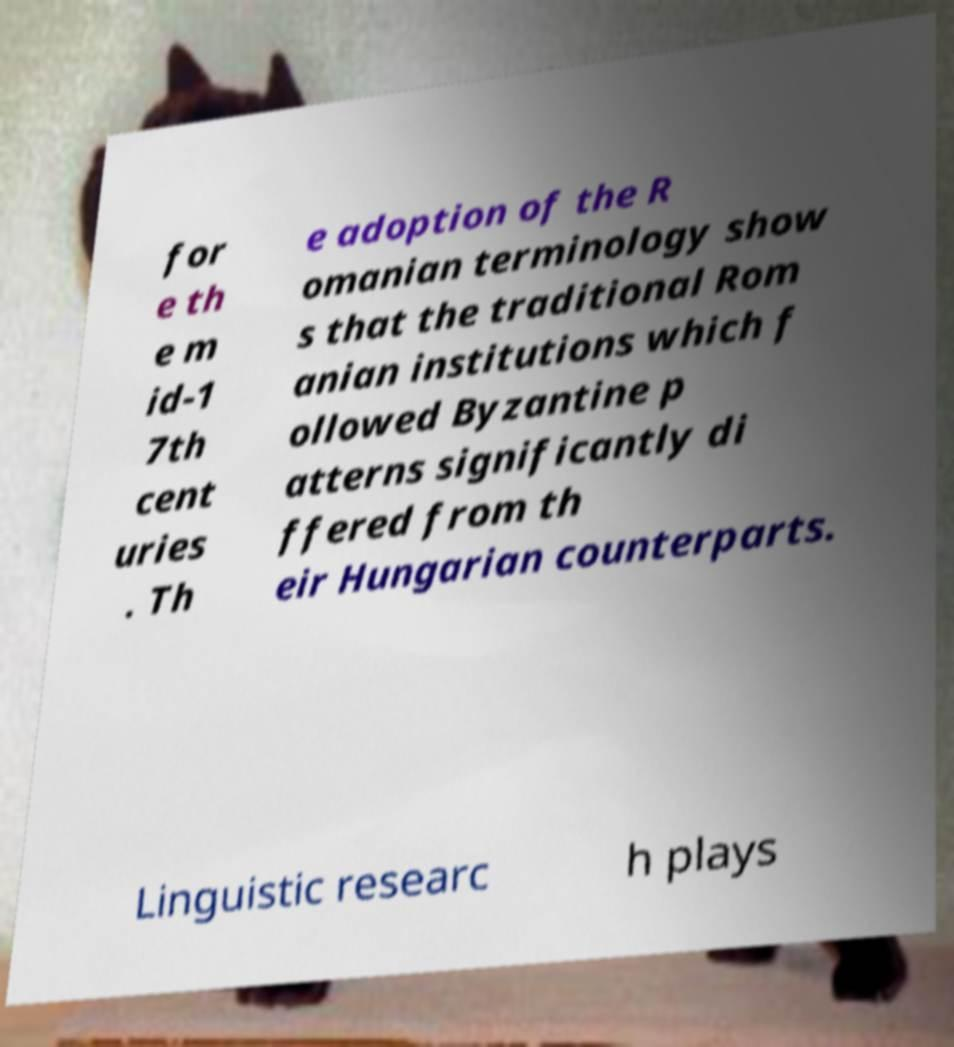What messages or text are displayed in this image? I need them in a readable, typed format. for e th e m id-1 7th cent uries . Th e adoption of the R omanian terminology show s that the traditional Rom anian institutions which f ollowed Byzantine p atterns significantly di ffered from th eir Hungarian counterparts. Linguistic researc h plays 